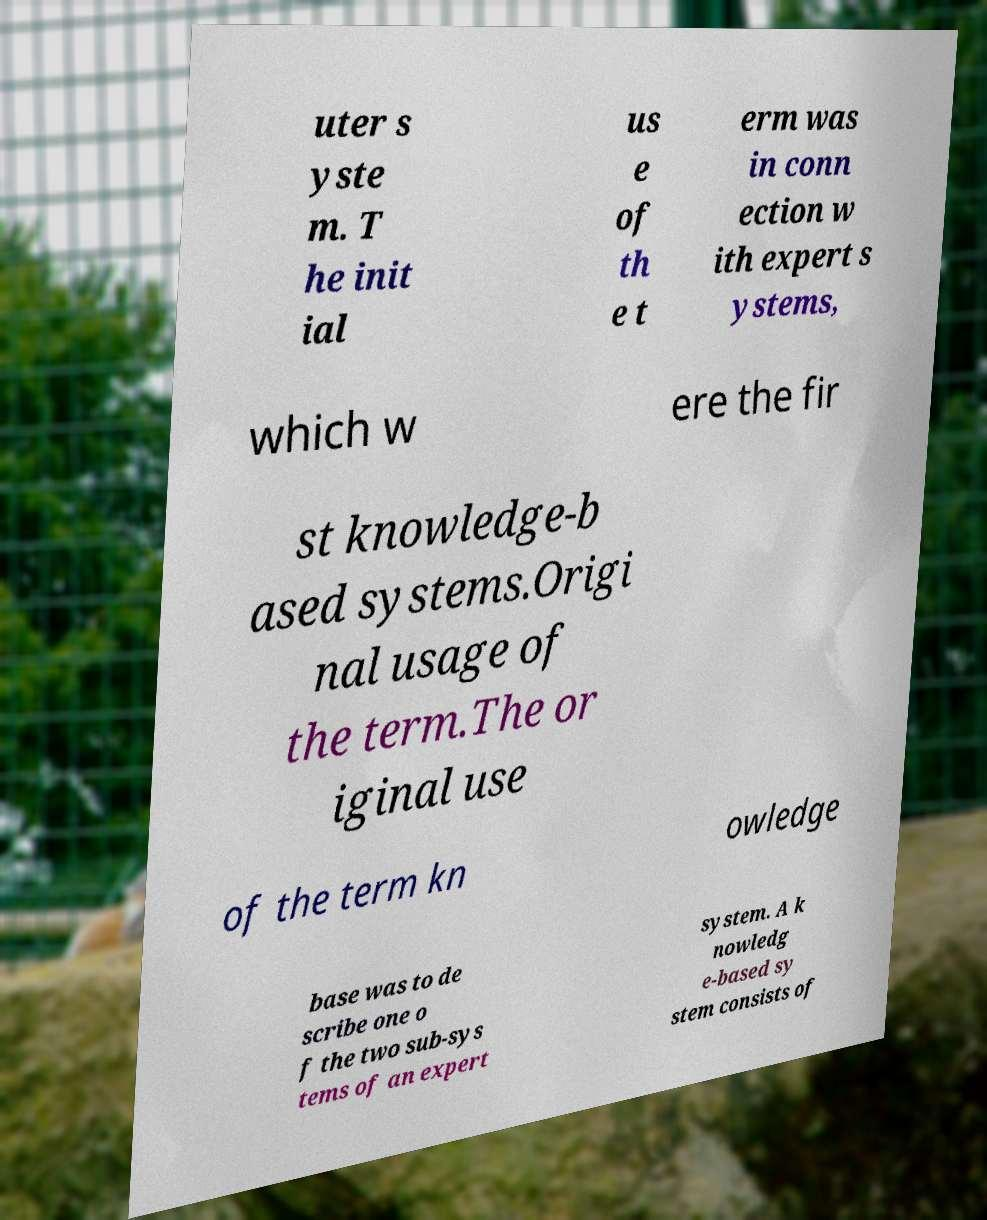For documentation purposes, I need the text within this image transcribed. Could you provide that? uter s yste m. T he init ial us e of th e t erm was in conn ection w ith expert s ystems, which w ere the fir st knowledge-b ased systems.Origi nal usage of the term.The or iginal use of the term kn owledge base was to de scribe one o f the two sub-sys tems of an expert system. A k nowledg e-based sy stem consists of 